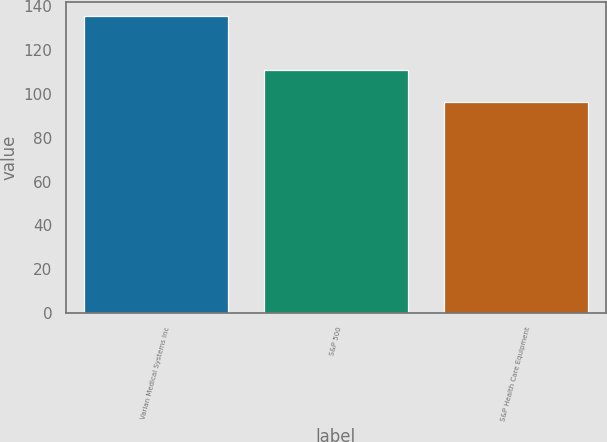Convert chart. <chart><loc_0><loc_0><loc_500><loc_500><bar_chart><fcel>Varian Medical Systems Inc<fcel>S&P 500<fcel>S&P Health Care Equipment<nl><fcel>135.13<fcel>110.79<fcel>96.42<nl></chart> 